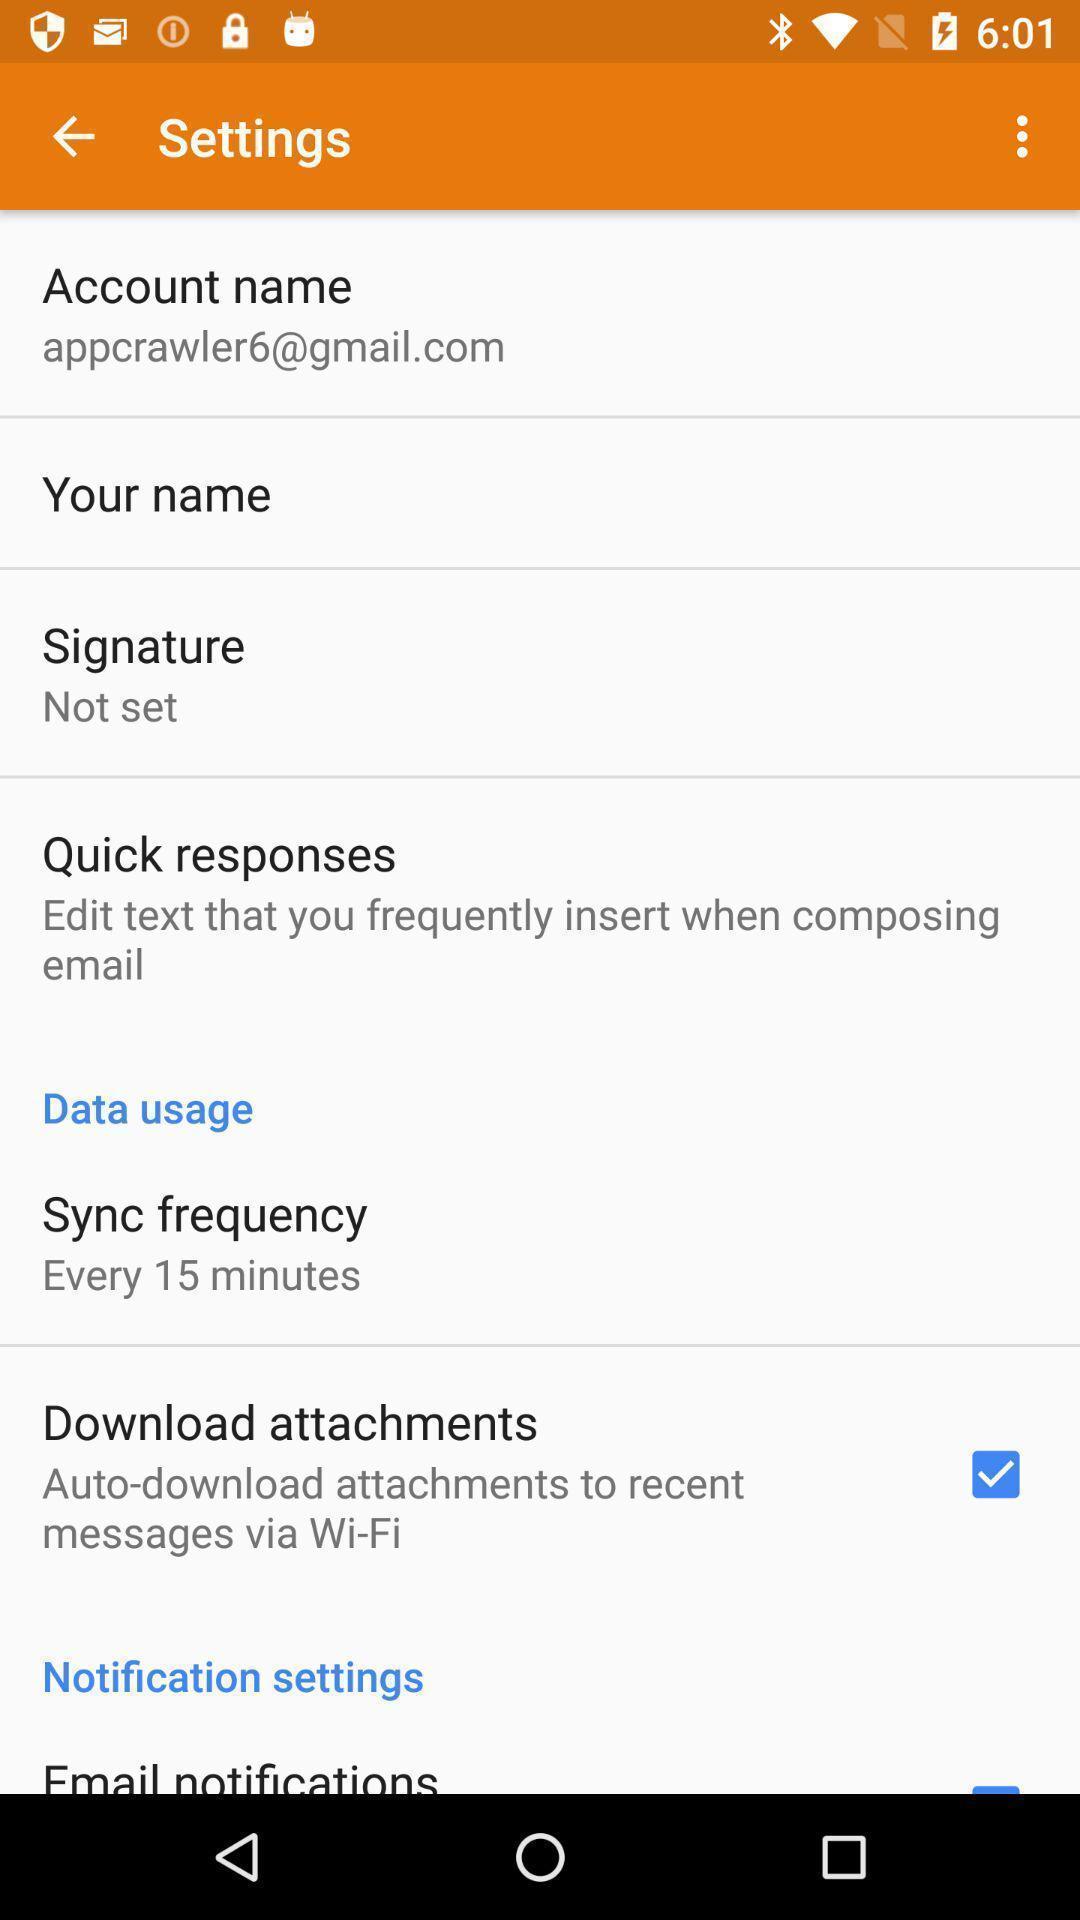Tell me what you see in this picture. Settings page of a messaging app. 